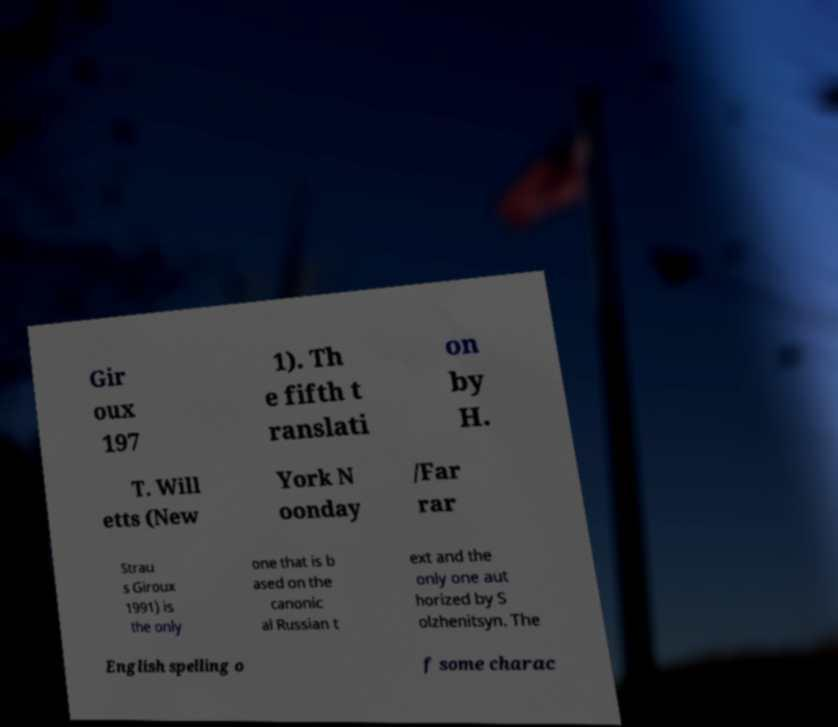For documentation purposes, I need the text within this image transcribed. Could you provide that? Gir oux 197 1). Th e fifth t ranslati on by H. T. Will etts (New York N oonday /Far rar Strau s Giroux 1991) is the only one that is b ased on the canonic al Russian t ext and the only one aut horized by S olzhenitsyn. The English spelling o f some charac 